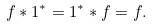<formula> <loc_0><loc_0><loc_500><loc_500>f * 1 ^ { * } = 1 ^ { * } * f = f .</formula> 